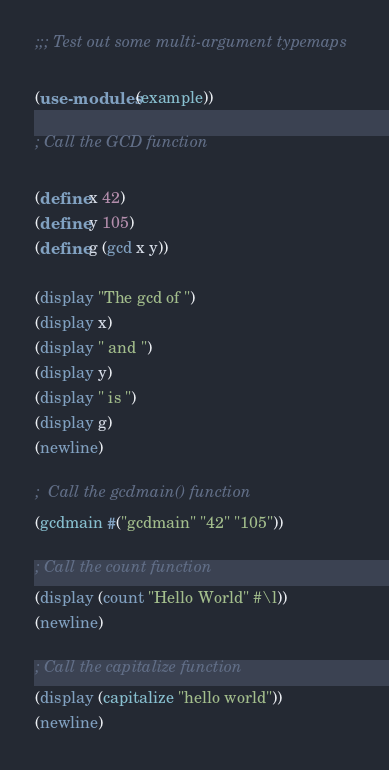<code> <loc_0><loc_0><loc_500><loc_500><_Scheme_>;;; Test out some multi-argument typemaps

(use-modules (example))

; Call the GCD function

(define x 42)
(define y 105)
(define g (gcd x y))

(display "The gcd of ")
(display x)
(display " and ")
(display y)
(display " is ")
(display g)
(newline)

;  Call the gcdmain() function
(gcdmain #("gcdmain" "42" "105"))

; Call the count function
(display (count "Hello World" #\l))
(newline)

; Call the capitalize function
(display (capitalize "hello world"))
(newline)


</code> 